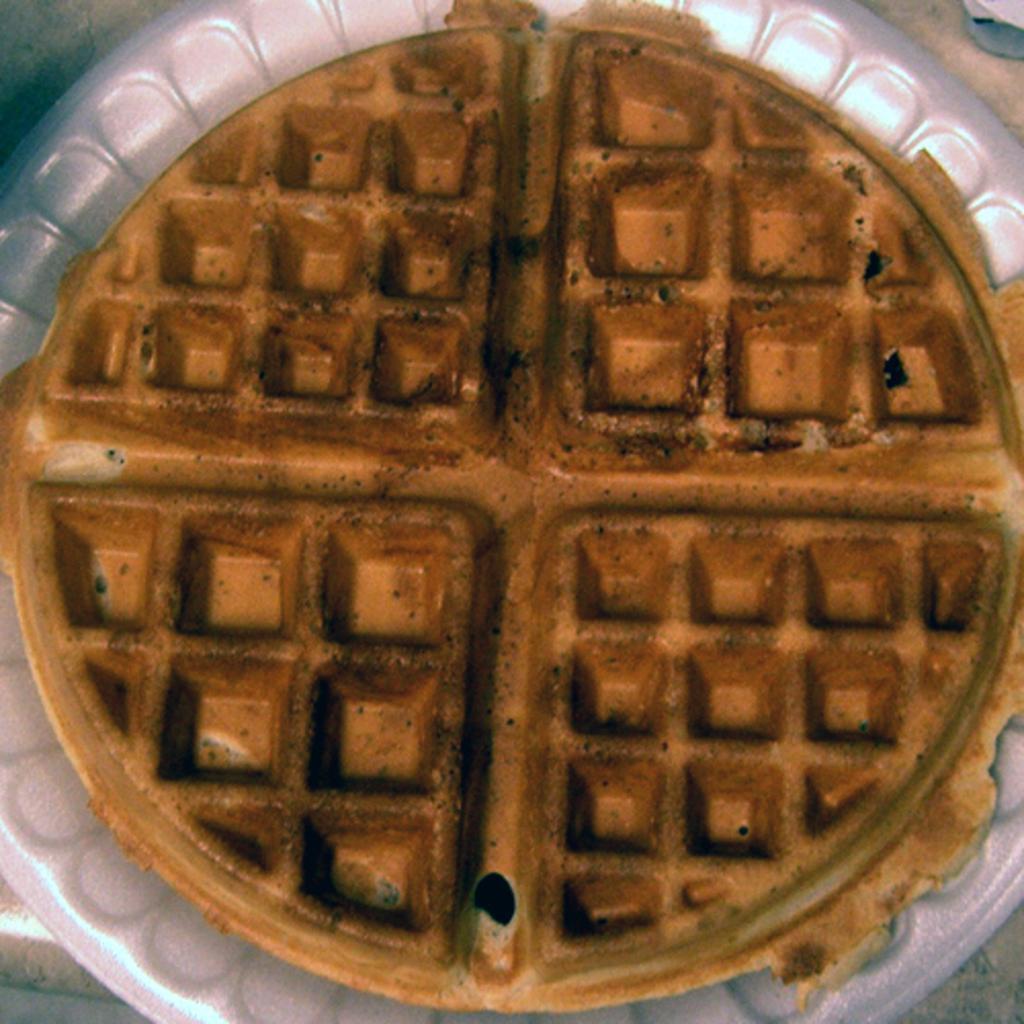In one or two sentences, can you explain what this image depicts? In this image there is a plate. On the plate there is a waffle. 